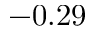<formula> <loc_0><loc_0><loc_500><loc_500>- 0 . 2 9</formula> 